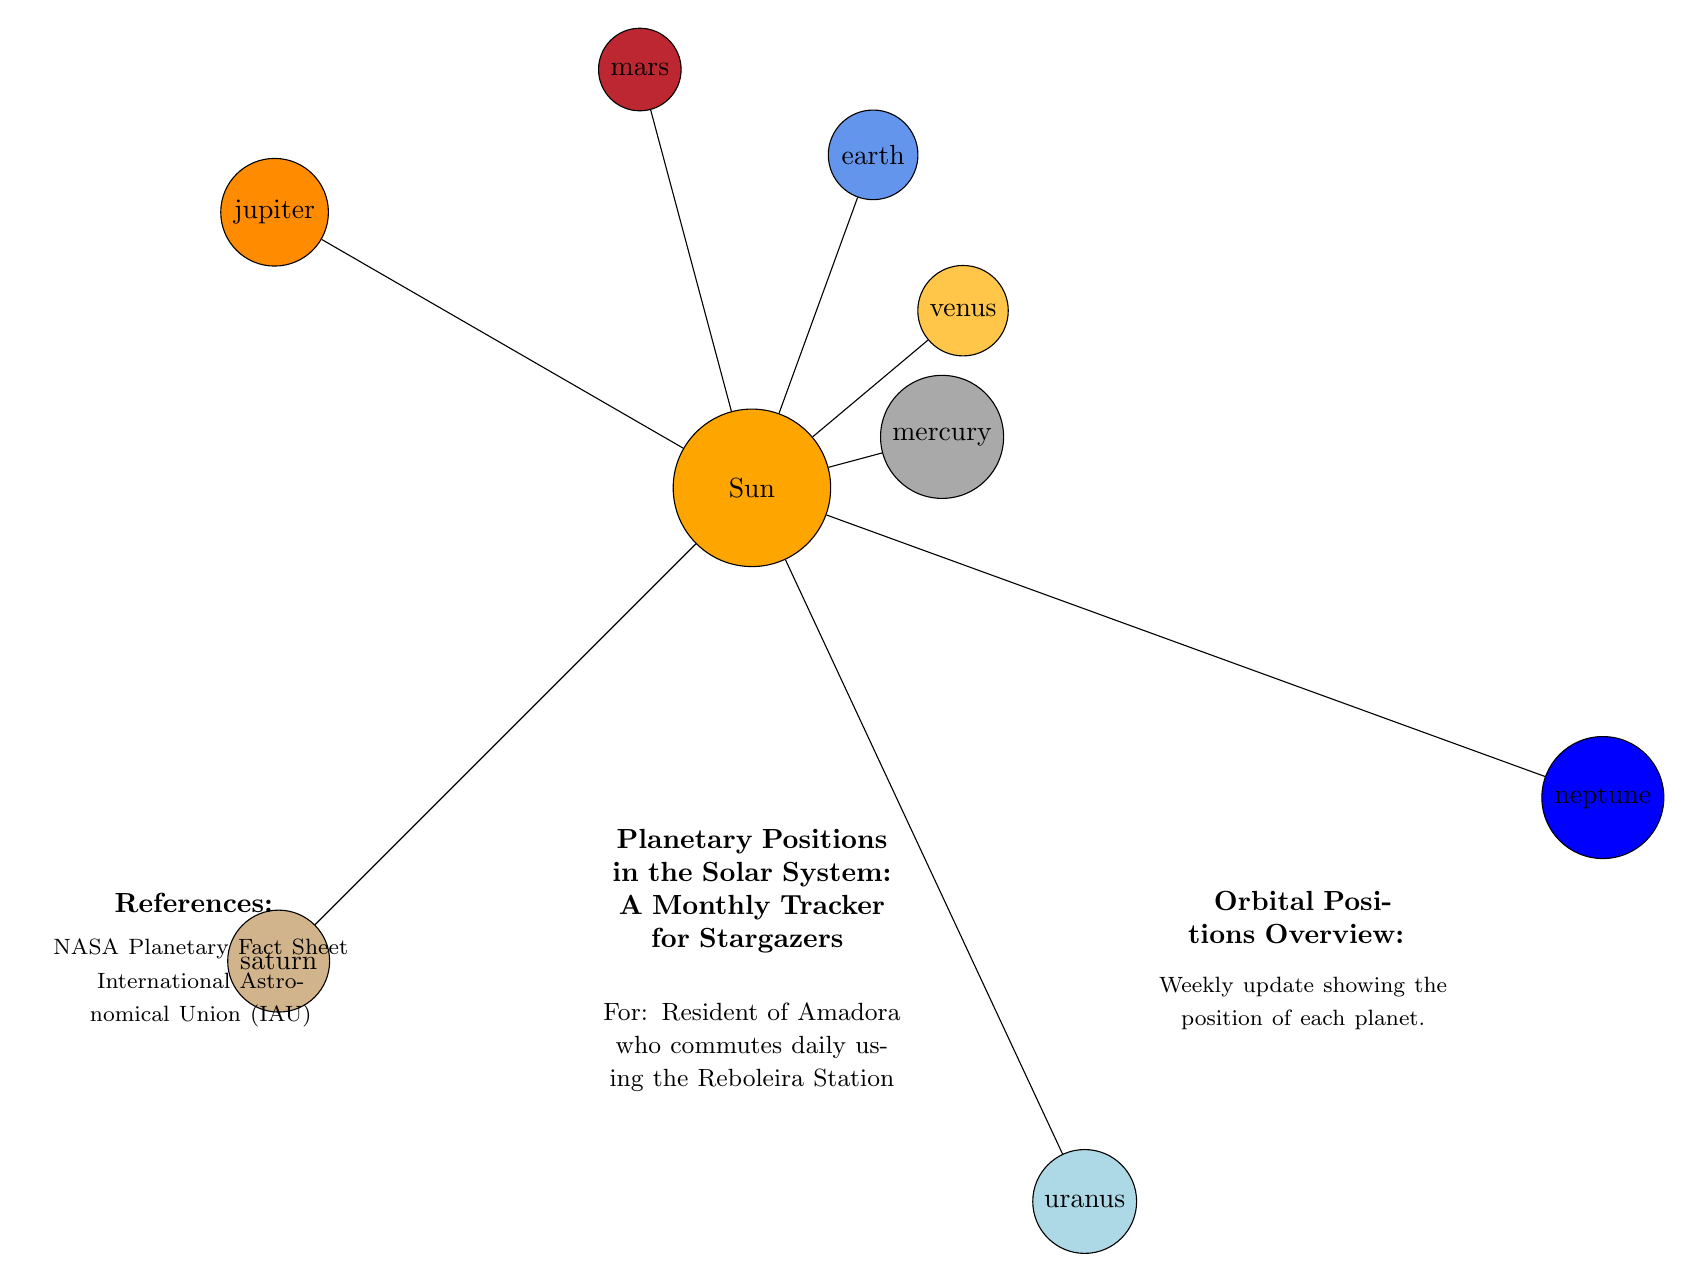What is the color of Venus in the diagram? The diagram uses a specific RGB value to define Venus's color, which is denoted as 'venuscolor' and is represented as 255,198,73. Therefore, its color in the diagram appears as a yellowish hue.
Answer: yellowish How many planets are there in the diagram? The diagram explicitly lists eight planets around the sun, including Mercury, Venus, Earth, Mars, Jupiter, Saturn, Uranus, and Neptune. Counting these gives us the total number of planets.
Answer: eight Which planet is closest to the Sun? The diagram places Mercury at the shortest radial distance from the Sun, making it the closest planet. The position is indicated as being at an angle of 15 degrees and a distance of 2.5 cm from the Sun.
Answer: Mercury What is the approximate angle of Mars in the diagram? In the diagram, Mars is positioned at an angle of 105 degrees from the Sun. This angular position is noted specifically for Mars in the data that generates the diagram.
Answer: 105 degrees Which planets are positioned beyond Saturn? According to the diagram, both Uranus and Neptune are located beyond Saturn's position, with Uranus at 295 degrees and Neptune at 340 degrees. These planets are marked with their respective position angles and distances, confirming their placement.
Answer: Uranus, Neptune What is the distance of Saturn from the Sun? The distance from the Sun to Saturn, as shown in the diagram, is specified as 8.5 cm. This measurement is part of the data used for visual placement of the planets relative to the Sun in the diagram.
Answer: 8.5 cm Is Jupiter larger or smaller than Earth in the diagram? In the diagram, Jupiter has a defined size of 1.2 cm, while Earth has a size of 0.7 cm. By comparing these sizes, we can conclude that Jupiter is larger than Earth.
Answer: Larger What does the diagram represent? The diagram is a visual representation tracking "Planetary Positions in the Solar System" for stargazers, providing information on the relative positions of planets around the sun. The title of the diagram specifies this purpose clearly.
Answer: Planetary Positions in the Solar System How many planets have a size less than 1 cm? Analyzing the planet sizes listed in the diagram details shows that Mercury (0.4 cm), Venus (0.6 cm), Earth (0.7 cm), and Mars (0.5 cm) all have sizes less than 1 cm. Counting these planets gives us the total quantity.
Answer: four 